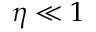Convert formula to latex. <formula><loc_0><loc_0><loc_500><loc_500>\eta \ll 1</formula> 